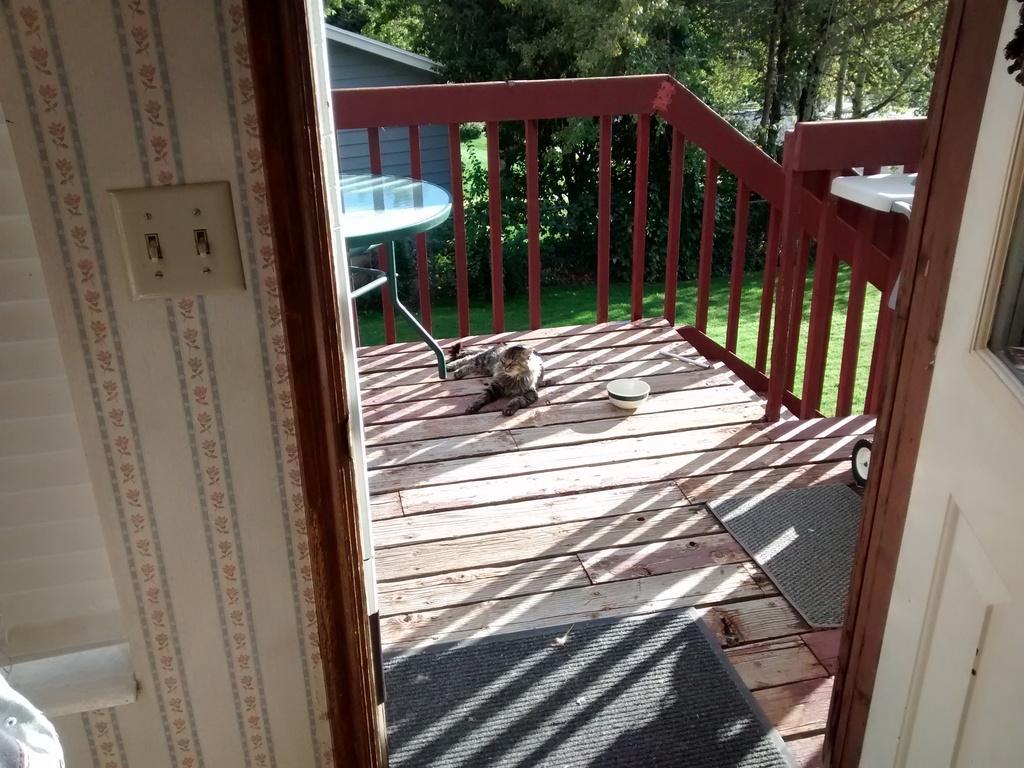In one or two sentences, can you explain what this image depicts? On the left side, there is a switchboard attached to the wall. On the right side, there is a white color door. In the background, there is a cat on the wooden floor, on which there is a white color cup and a table, there is a fence, there are trees, a building and there's grass on the ground. 